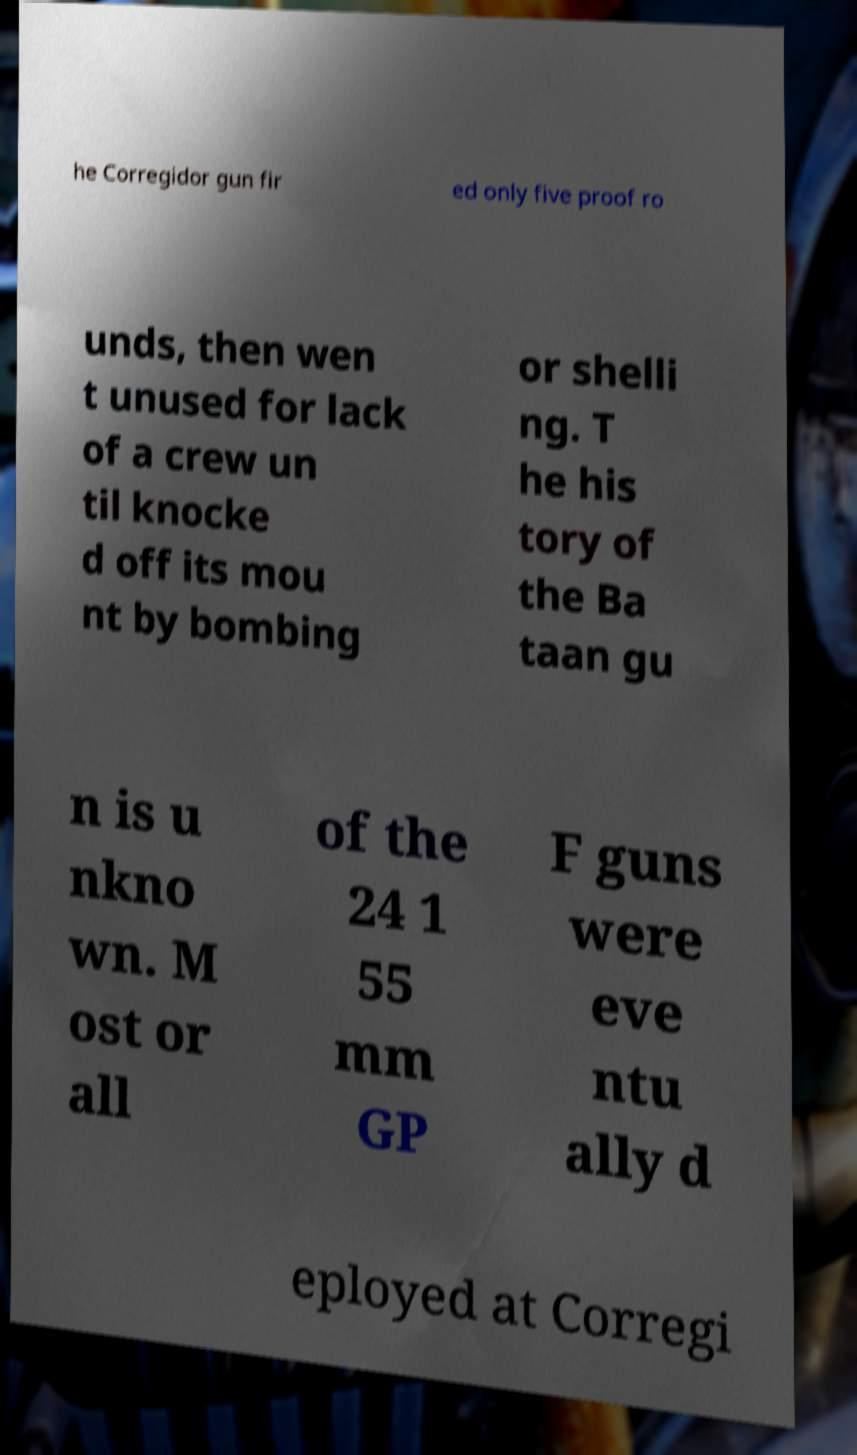There's text embedded in this image that I need extracted. Can you transcribe it verbatim? he Corregidor gun fir ed only five proof ro unds, then wen t unused for lack of a crew un til knocke d off its mou nt by bombing or shelli ng. T he his tory of the Ba taan gu n is u nkno wn. M ost or all of the 24 1 55 mm GP F guns were eve ntu ally d eployed at Corregi 